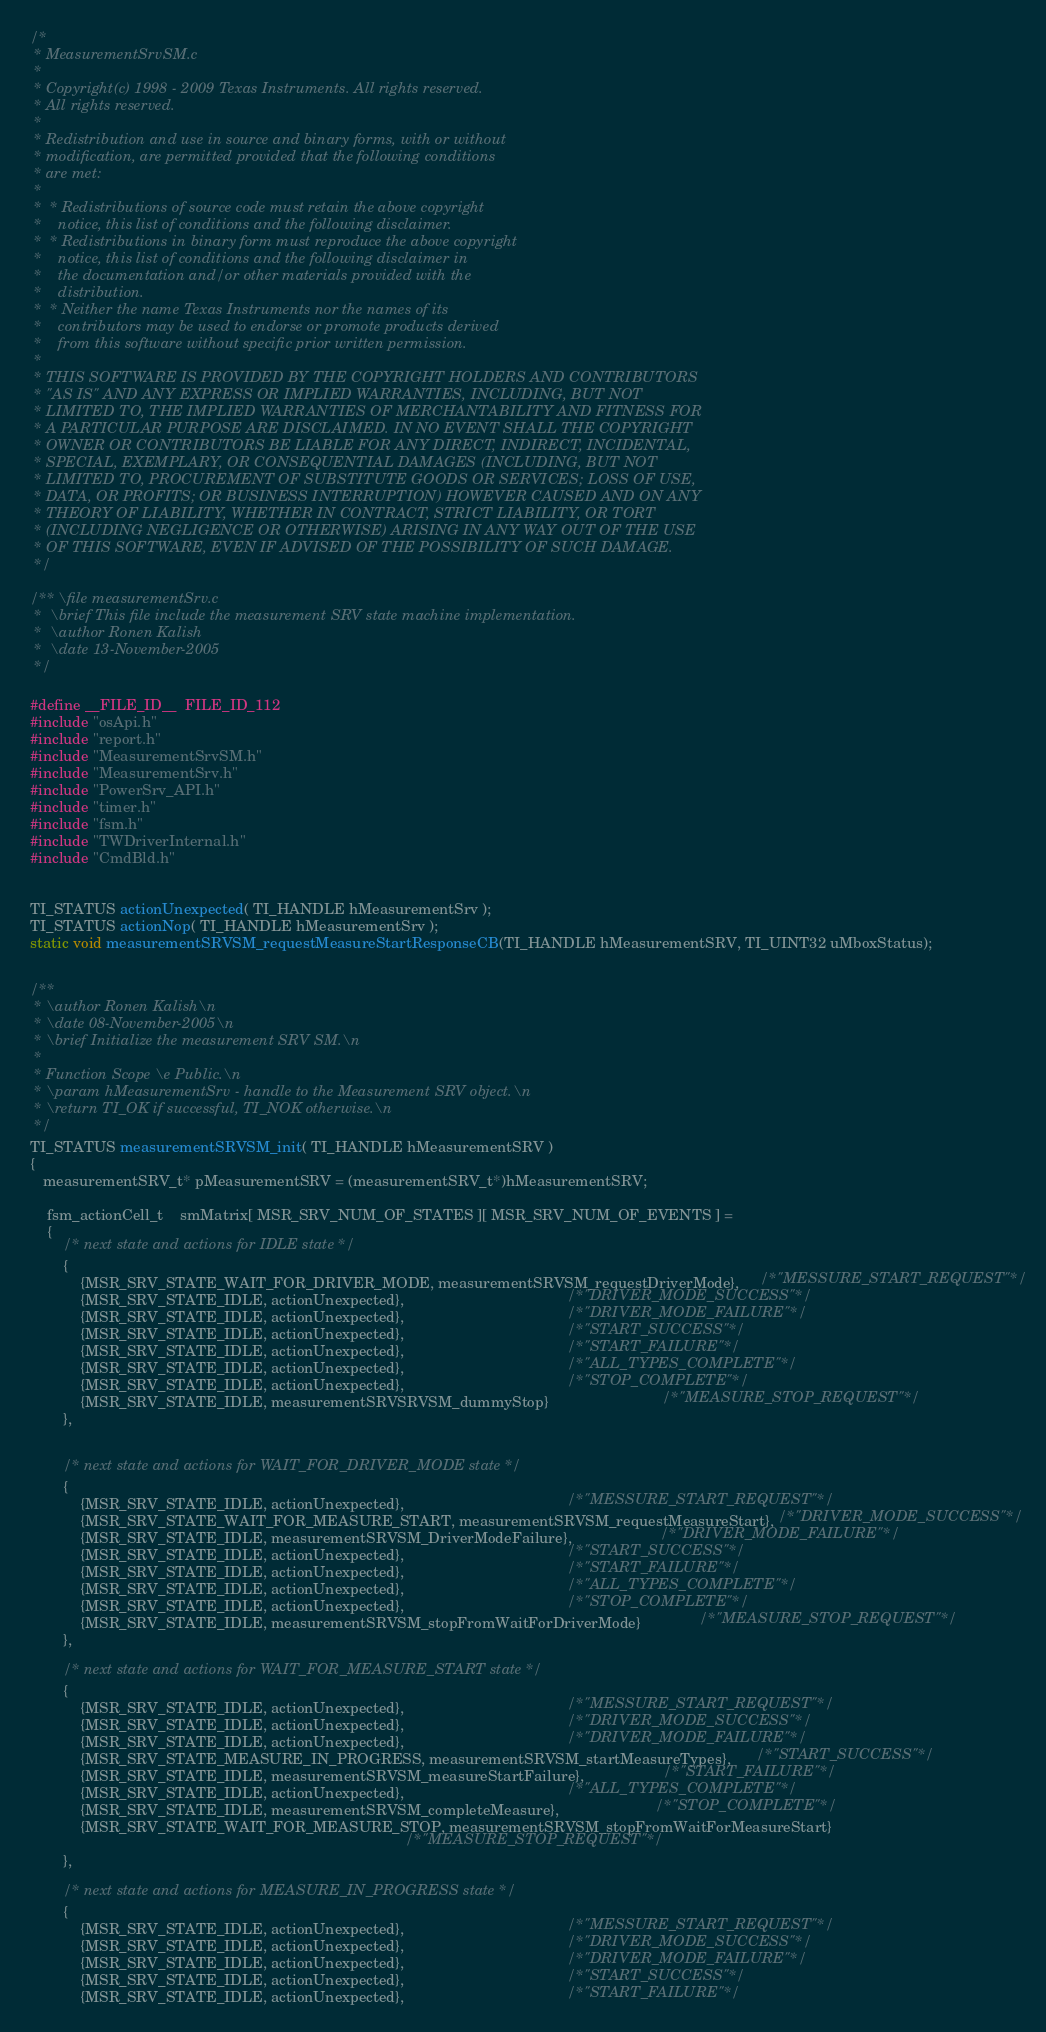<code> <loc_0><loc_0><loc_500><loc_500><_C_>/*
 * MeasurementSrvSM.c
 *
 * Copyright(c) 1998 - 2009 Texas Instruments. All rights reserved.      
 * All rights reserved.                                                  
 *                                                                       
 * Redistribution and use in source and binary forms, with or without    
 * modification, are permitted provided that the following conditions    
 * are met:                                                              
 *                                                                       
 *  * Redistributions of source code must retain the above copyright     
 *    notice, this list of conditions and the following disclaimer.      
 *  * Redistributions in binary form must reproduce the above copyright  
 *    notice, this list of conditions and the following disclaimer in    
 *    the documentation and/or other materials provided with the         
 *    distribution.                                                      
 *  * Neither the name Texas Instruments nor the names of its            
 *    contributors may be used to endorse or promote products derived    
 *    from this software without specific prior written permission.      
 *                                                                       
 * THIS SOFTWARE IS PROVIDED BY THE COPYRIGHT HOLDERS AND CONTRIBUTORS   
 * "AS IS" AND ANY EXPRESS OR IMPLIED WARRANTIES, INCLUDING, BUT NOT     
 * LIMITED TO, THE IMPLIED WARRANTIES OF MERCHANTABILITY AND FITNESS FOR 
 * A PARTICULAR PURPOSE ARE DISCLAIMED. IN NO EVENT SHALL THE COPYRIGHT  
 * OWNER OR CONTRIBUTORS BE LIABLE FOR ANY DIRECT, INDIRECT, INCIDENTAL, 
 * SPECIAL, EXEMPLARY, OR CONSEQUENTIAL DAMAGES (INCLUDING, BUT NOT      
 * LIMITED TO, PROCUREMENT OF SUBSTITUTE GOODS OR SERVICES; LOSS OF USE, 
 * DATA, OR PROFITS; OR BUSINESS INTERRUPTION) HOWEVER CAUSED AND ON ANY 
 * THEORY OF LIABILITY, WHETHER IN CONTRACT, STRICT LIABILITY, OR TORT   
 * (INCLUDING NEGLIGENCE OR OTHERWISE) ARISING IN ANY WAY OUT OF THE USE 
 * OF THIS SOFTWARE, EVEN IF ADVISED OF THE POSSIBILITY OF SUCH DAMAGE.
 */

/** \file measurementSrv.c
 *  \brief This file include the measurement SRV state machine implementation.
 *  \author Ronen Kalish
 *  \date 13-November-2005
 */

#define __FILE_ID__  FILE_ID_112
#include "osApi.h"
#include "report.h"
#include "MeasurementSrvSM.h"
#include "MeasurementSrv.h"
#include "PowerSrv_API.h"
#include "timer.h"
#include "fsm.h"
#include "TWDriverInternal.h"
#include "CmdBld.h"


TI_STATUS actionUnexpected( TI_HANDLE hMeasurementSrv );
TI_STATUS actionNop( TI_HANDLE hMeasurementSrv );
static void measurementSRVSM_requestMeasureStartResponseCB(TI_HANDLE hMeasurementSRV, TI_UINT32 uMboxStatus);


/**
 * \author Ronen Kalish\n
 * \date 08-November-2005\n
 * \brief Initialize the measurement SRV SM.\n
 *
 * Function Scope \e Public.\n
 * \param hMeasurementSrv - handle to the Measurement SRV object.\n
 * \return TI_OK if successful, TI_NOK otherwise.\n
 */
TI_STATUS measurementSRVSM_init( TI_HANDLE hMeasurementSRV )
{
   measurementSRV_t* pMeasurementSRV = (measurementSRV_t*)hMeasurementSRV;

    fsm_actionCell_t    smMatrix[ MSR_SRV_NUM_OF_STATES ][ MSR_SRV_NUM_OF_EVENTS ] =
    {
        /* next state and actions for IDLE state */
        {   
            {MSR_SRV_STATE_WAIT_FOR_DRIVER_MODE, measurementSRVSM_requestDriverMode},     /*"MESSURE_START_REQUEST"*/
            {MSR_SRV_STATE_IDLE, actionUnexpected},                                       /*"DRIVER_MODE_SUCCESS"*/
            {MSR_SRV_STATE_IDLE, actionUnexpected},                                       /*"DRIVER_MODE_FAILURE"*/
            {MSR_SRV_STATE_IDLE, actionUnexpected},                                       /*"START_SUCCESS"*/
            {MSR_SRV_STATE_IDLE, actionUnexpected},                                       /*"START_FAILURE"*/
            {MSR_SRV_STATE_IDLE, actionUnexpected},                                       /*"ALL_TYPES_COMPLETE"*/
            {MSR_SRV_STATE_IDLE, actionUnexpected},                                       /*"STOP_COMPLETE"*/
            {MSR_SRV_STATE_IDLE, measurementSRVSRVSM_dummyStop}                           /*"MEASURE_STOP_REQUEST"*/
        },


        /* next state and actions for WAIT_FOR_DRIVER_MODE state */
        {   
            {MSR_SRV_STATE_IDLE, actionUnexpected},                                       /*"MESSURE_START_REQUEST"*/
            {MSR_SRV_STATE_WAIT_FOR_MEASURE_START, measurementSRVSM_requestMeasureStart}, /*"DRIVER_MODE_SUCCESS"*/
            {MSR_SRV_STATE_IDLE, measurementSRVSM_DriverModeFailure},                     /*"DRIVER_MODE_FAILURE"*/
            {MSR_SRV_STATE_IDLE, actionUnexpected},                                       /*"START_SUCCESS"*/
            {MSR_SRV_STATE_IDLE, actionUnexpected},                                       /*"START_FAILURE"*/
            {MSR_SRV_STATE_IDLE, actionUnexpected},                                       /*"ALL_TYPES_COMPLETE"*/
            {MSR_SRV_STATE_IDLE, actionUnexpected},                                       /*"STOP_COMPLETE"*/
            {MSR_SRV_STATE_IDLE, measurementSRVSM_stopFromWaitForDriverMode}              /*"MEASURE_STOP_REQUEST"*/
        },

        /* next state and actions for WAIT_FOR_MEASURE_START state */
        {    
            {MSR_SRV_STATE_IDLE, actionUnexpected},                                       /*"MESSURE_START_REQUEST"*/
            {MSR_SRV_STATE_IDLE, actionUnexpected},                                       /*"DRIVER_MODE_SUCCESS"*/
            {MSR_SRV_STATE_IDLE, actionUnexpected},                                       /*"DRIVER_MODE_FAILURE"*/
            {MSR_SRV_STATE_MEASURE_IN_PROGRESS, measurementSRVSM_startMeasureTypes},      /*"START_SUCCESS"*/
            {MSR_SRV_STATE_IDLE, measurementSRVSM_measureStartFailure},                   /*"START_FAILURE"*/
            {MSR_SRV_STATE_IDLE, actionUnexpected},                                       /*"ALL_TYPES_COMPLETE"*/
            {MSR_SRV_STATE_IDLE, measurementSRVSM_completeMeasure},                       /*"STOP_COMPLETE"*/
            {MSR_SRV_STATE_WAIT_FOR_MEASURE_STOP, measurementSRVSM_stopFromWaitForMeasureStart}
                                                                                          /*"MEASURE_STOP_REQUEST"*/
        },

        /* next state and actions for MEASURE_IN_PROGRESS state */
        {   
            {MSR_SRV_STATE_IDLE, actionUnexpected},                                       /*"MESSURE_START_REQUEST"*/
            {MSR_SRV_STATE_IDLE, actionUnexpected},                                       /*"DRIVER_MODE_SUCCESS"*/
            {MSR_SRV_STATE_IDLE, actionUnexpected},                                       /*"DRIVER_MODE_FAILURE"*/
            {MSR_SRV_STATE_IDLE, actionUnexpected},                                       /*"START_SUCCESS"*/
            {MSR_SRV_STATE_IDLE, actionUnexpected},                                       /*"START_FAILURE"*/</code> 